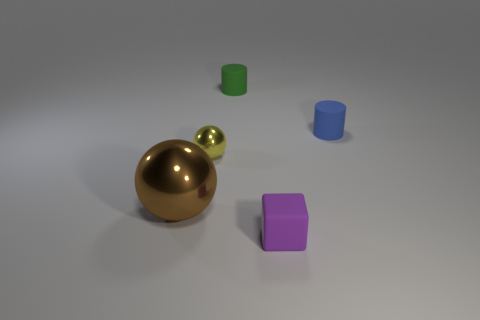Add 2 brown shiny balls. How many objects exist? 7 Subtract all green cylinders. How many cylinders are left? 1 Subtract all cubes. How many objects are left? 4 Subtract 1 cubes. How many cubes are left? 0 Subtract all brown cylinders. Subtract all cyan balls. How many cylinders are left? 2 Subtract all big green shiny balls. Subtract all small rubber objects. How many objects are left? 2 Add 1 tiny blue matte cylinders. How many tiny blue matte cylinders are left? 2 Add 2 tiny red matte cubes. How many tiny red matte cubes exist? 2 Subtract 1 green cylinders. How many objects are left? 4 